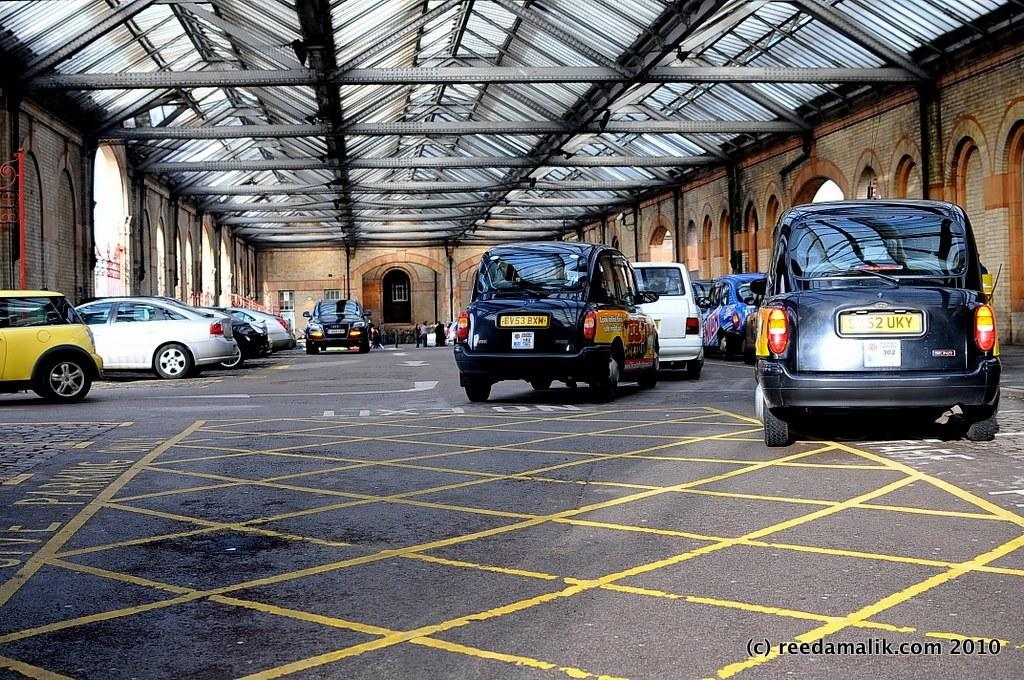<image>
Relay a brief, clear account of the picture shown. Vehicles parked outside a building with a license plate on the rear BV53BXH. 